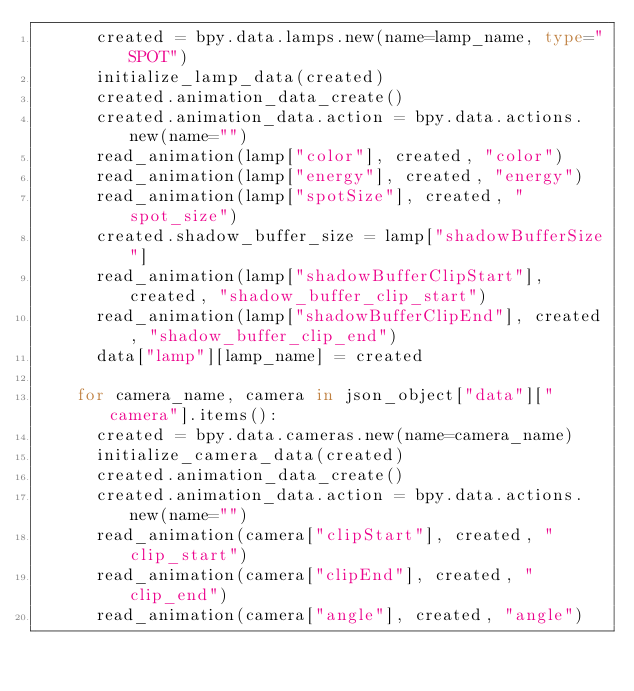Convert code to text. <code><loc_0><loc_0><loc_500><loc_500><_Python_>      created = bpy.data.lamps.new(name=lamp_name, type="SPOT")
      initialize_lamp_data(created)
      created.animation_data_create()
      created.animation_data.action = bpy.data.actions.new(name="")
      read_animation(lamp["color"], created, "color")
      read_animation(lamp["energy"], created, "energy")
      read_animation(lamp["spotSize"], created, "spot_size")
      created.shadow_buffer_size = lamp["shadowBufferSize"]
      read_animation(lamp["shadowBufferClipStart"], created, "shadow_buffer_clip_start")
      read_animation(lamp["shadowBufferClipEnd"], created, "shadow_buffer_clip_end")
      data["lamp"][lamp_name] = created

    for camera_name, camera in json_object["data"]["camera"].items():
      created = bpy.data.cameras.new(name=camera_name)
      initialize_camera_data(created)
      created.animation_data_create()
      created.animation_data.action = bpy.data.actions.new(name="")
      read_animation(camera["clipStart"], created, "clip_start")
      read_animation(camera["clipEnd"], created, "clip_end")
      read_animation(camera["angle"], created, "angle")</code> 